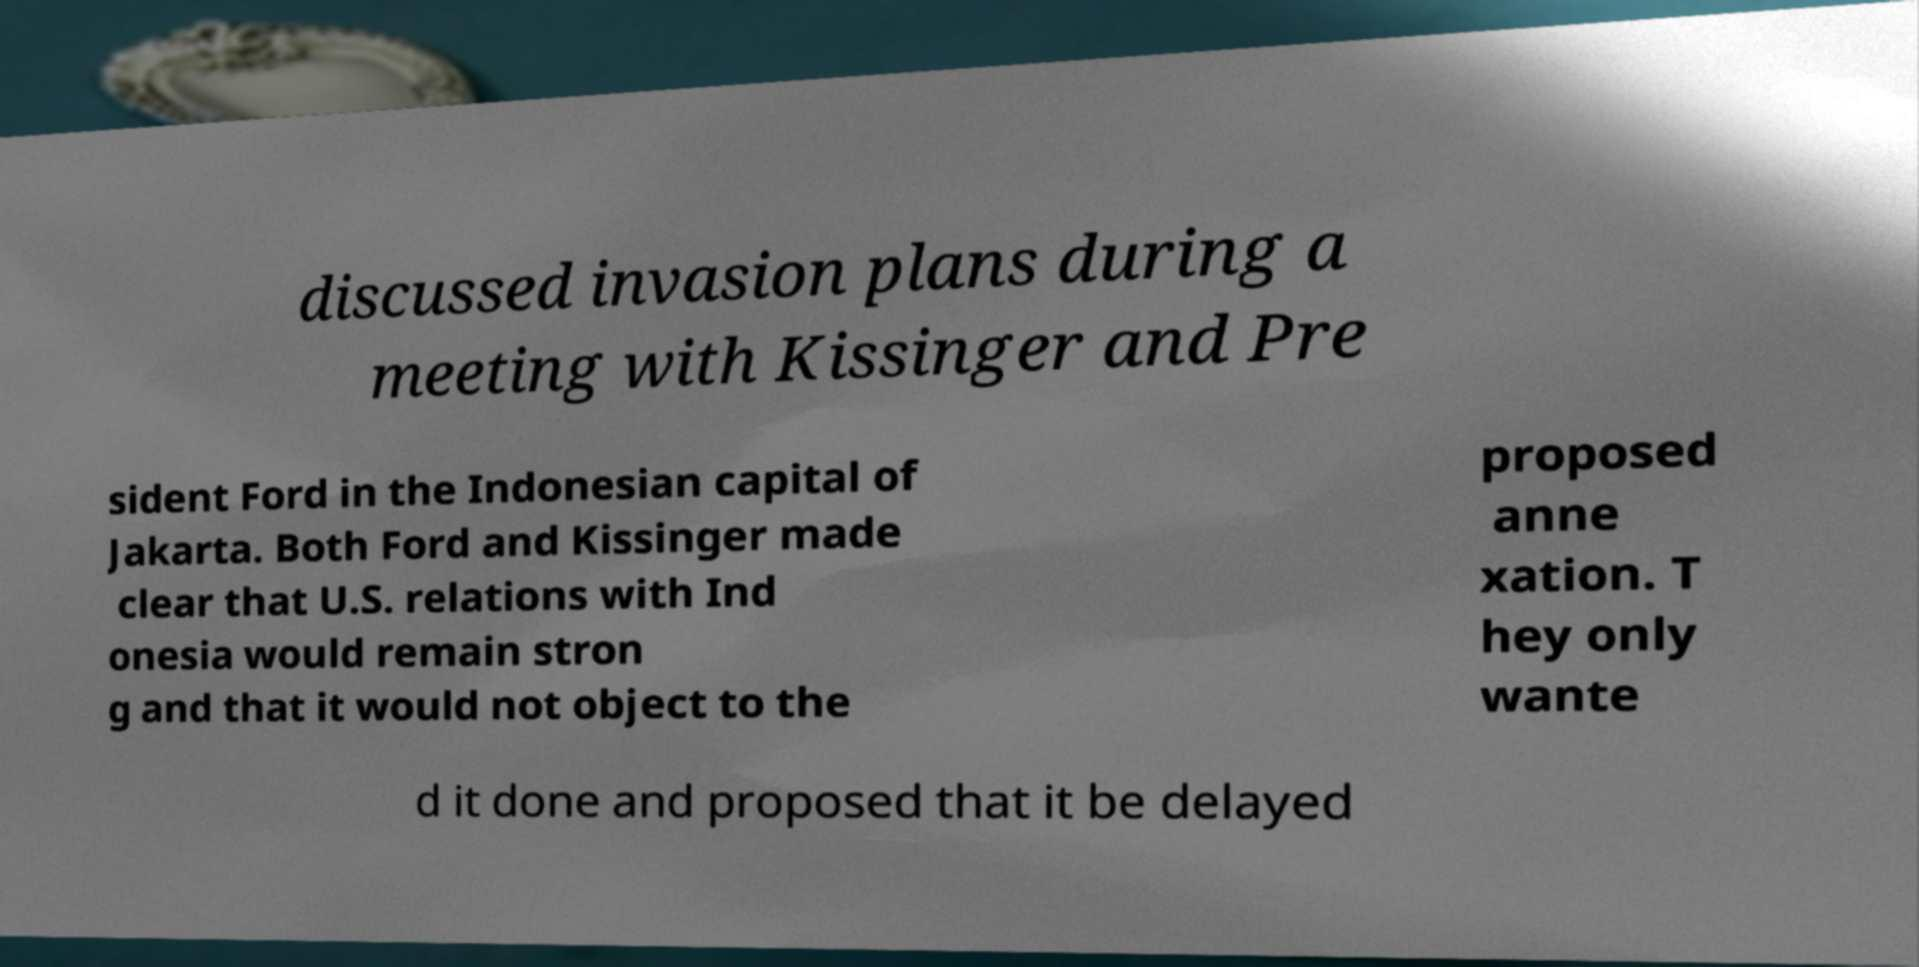Could you extract and type out the text from this image? discussed invasion plans during a meeting with Kissinger and Pre sident Ford in the Indonesian capital of Jakarta. Both Ford and Kissinger made clear that U.S. relations with Ind onesia would remain stron g and that it would not object to the proposed anne xation. T hey only wante d it done and proposed that it be delayed 